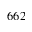Convert formula to latex. <formula><loc_0><loc_0><loc_500><loc_500>6 6 2</formula> 